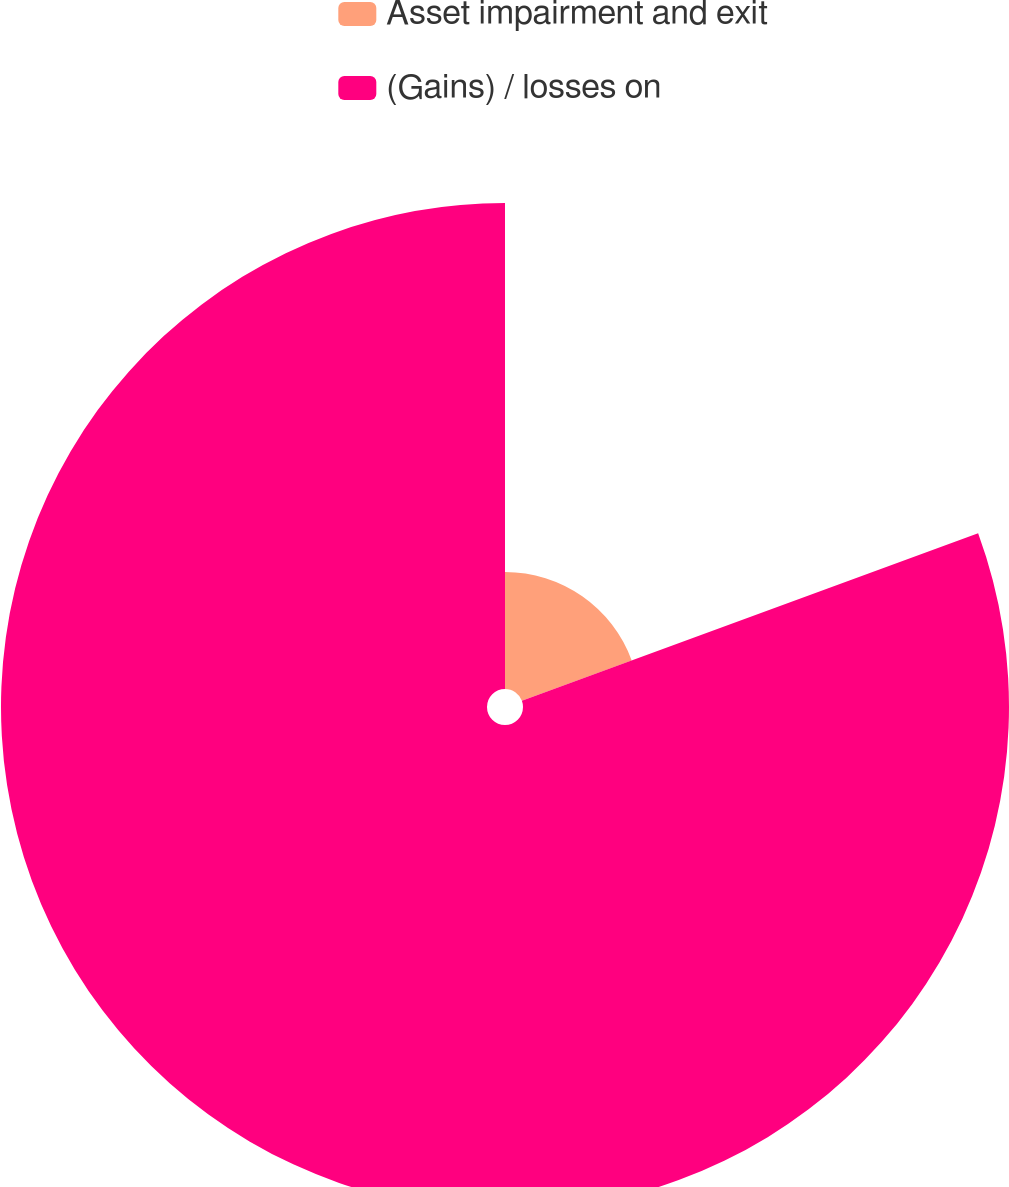<chart> <loc_0><loc_0><loc_500><loc_500><pie_chart><fcel>Asset impairment and exit<fcel>(Gains) / losses on<nl><fcel>19.4%<fcel>80.6%<nl></chart> 